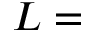Convert formula to latex. <formula><loc_0><loc_0><loc_500><loc_500>L =</formula> 